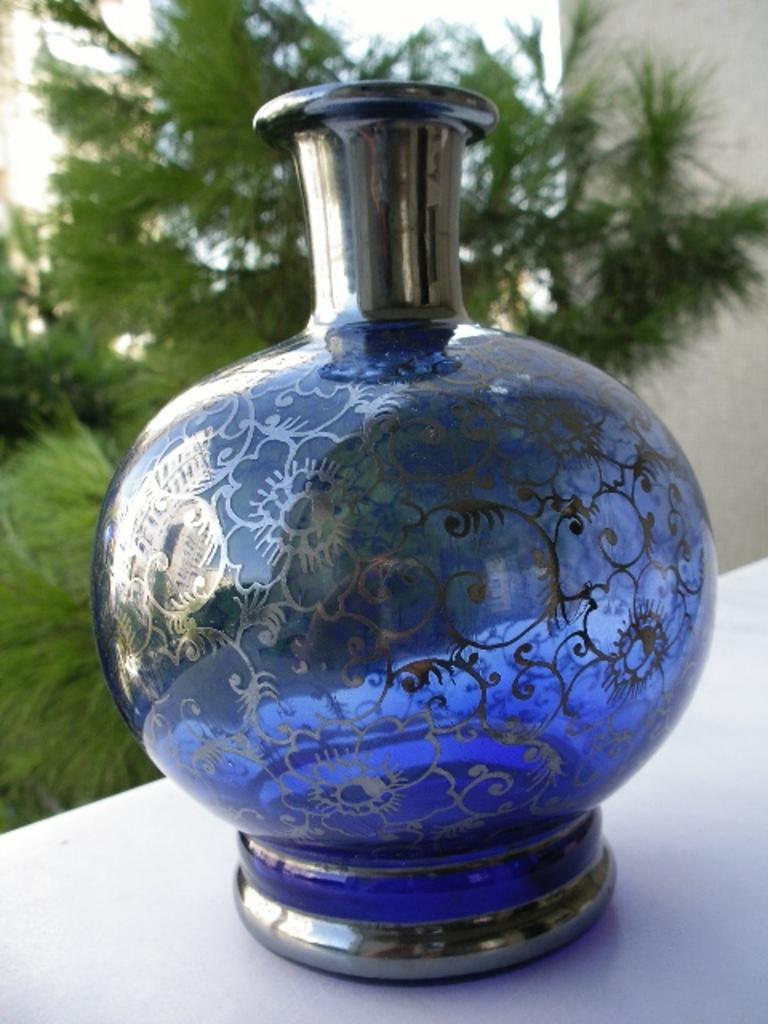What is the main object in the center of the image? There is a blue color glass vase in the center of the image. What can you tell about the color of the vase? The vase is blue in color. How would you describe the background of the image? The background of the image is blurred. Can you see a cow smiling in the image? There is no cow or any indication of a smile in the image; it features a blue color glass vase in the center. What type of pot is used to hold the vase in the image? There is no pot present in the image; it only shows a blue color glass vase in the center. 